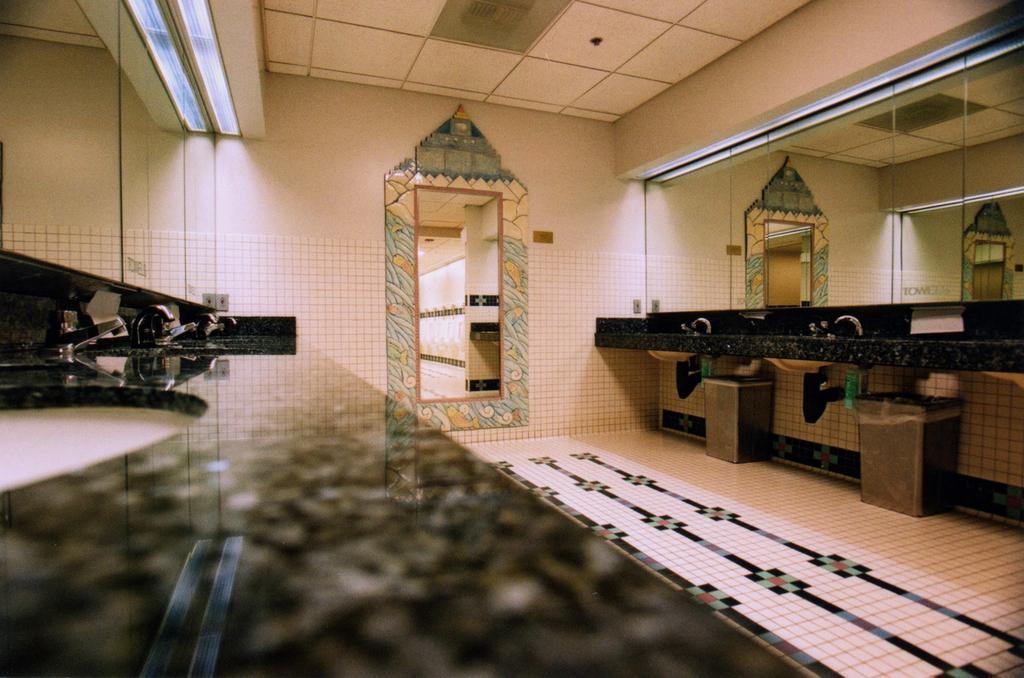Could you give a brief overview of what you see in this image? This is the picture of a room. On the left side of the image there is a sink and there are tapes. On the right side of the image there are tapes. At the top there are lights. At the back there is a mirror. At the bottom are tiles and dustbins. On the left and on the right side of the image there are mirrors. 